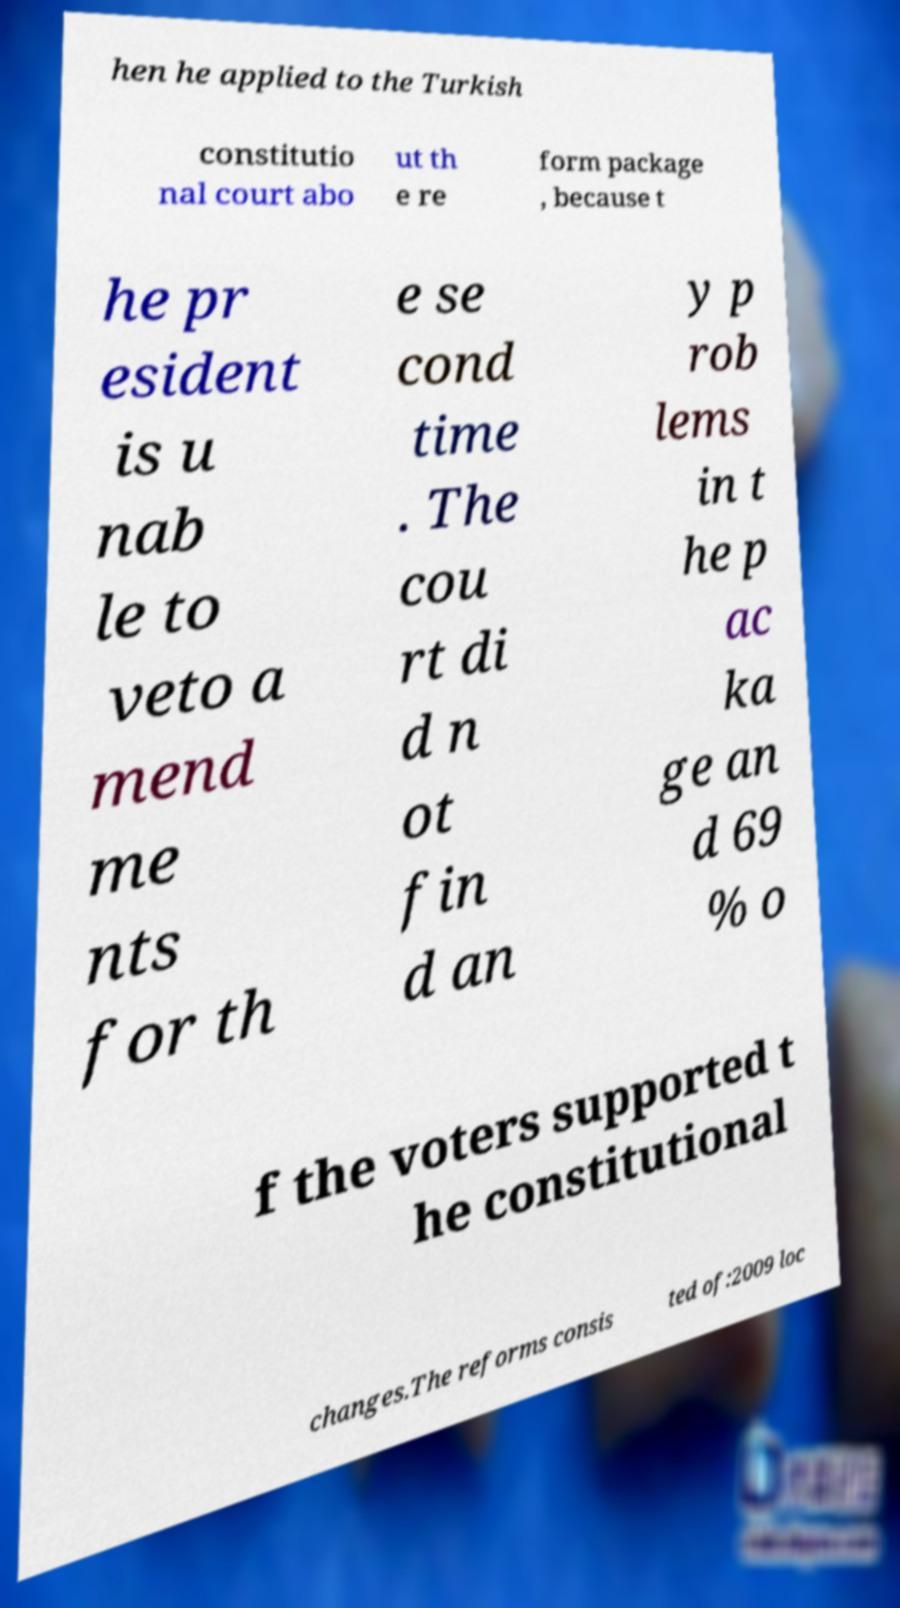Could you assist in decoding the text presented in this image and type it out clearly? hen he applied to the Turkish constitutio nal court abo ut th e re form package , because t he pr esident is u nab le to veto a mend me nts for th e se cond time . The cou rt di d n ot fin d an y p rob lems in t he p ac ka ge an d 69 % o f the voters supported t he constitutional changes.The reforms consis ted of:2009 loc 